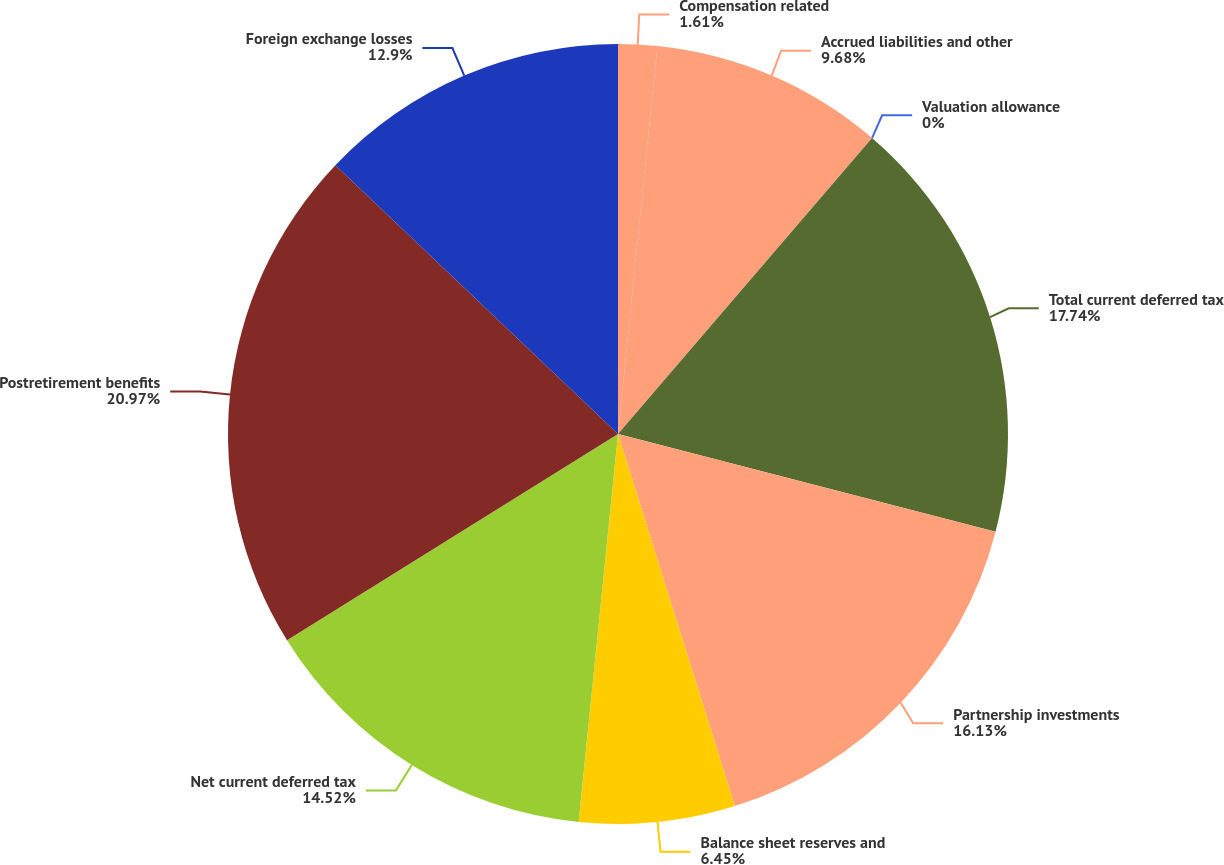Convert chart to OTSL. <chart><loc_0><loc_0><loc_500><loc_500><pie_chart><fcel>Compensation related<fcel>Accrued liabilities and other<fcel>Valuation allowance<fcel>Total current deferred tax<fcel>Partnership investments<fcel>Balance sheet reserves and<fcel>Net current deferred tax<fcel>Postretirement benefits<fcel>Foreign exchange losses<nl><fcel>1.61%<fcel>9.68%<fcel>0.0%<fcel>17.74%<fcel>16.13%<fcel>6.45%<fcel>14.52%<fcel>20.97%<fcel>12.9%<nl></chart> 